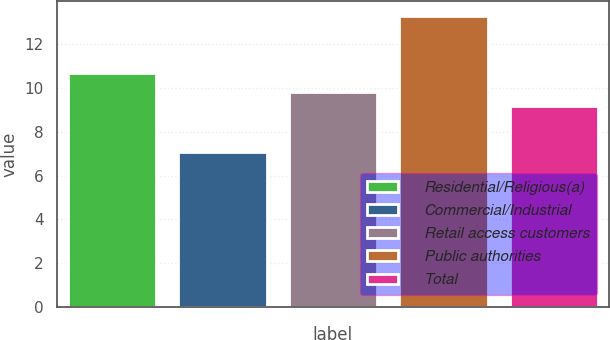Convert chart. <chart><loc_0><loc_0><loc_500><loc_500><bar_chart><fcel>Residential/Religious(a)<fcel>Commercial/Industrial<fcel>Retail access customers<fcel>Public authorities<fcel>Total<nl><fcel>10.7<fcel>7.1<fcel>9.82<fcel>13.3<fcel>9.2<nl></chart> 